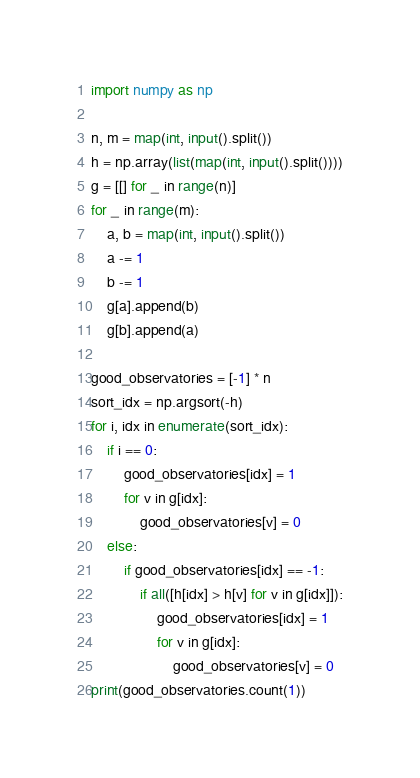Convert code to text. <code><loc_0><loc_0><loc_500><loc_500><_Python_>import numpy as np

n, m = map(int, input().split())
h = np.array(list(map(int, input().split())))
g = [[] for _ in range(n)] 
for _ in range(m):
    a, b = map(int, input().split())
    a -= 1
    b -= 1
    g[a].append(b)
    g[b].append(a)

good_observatories = [-1] * n
sort_idx = np.argsort(-h)
for i, idx in enumerate(sort_idx):
    if i == 0:
        good_observatories[idx] = 1
        for v in g[idx]:
            good_observatories[v] = 0
    else:
        if good_observatories[idx] == -1:
            if all([h[idx] > h[v] for v in g[idx]]):
                good_observatories[idx] = 1
                for v in g[idx]:
                    good_observatories[v] = 0
print(good_observatories.count(1))
</code> 